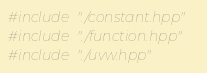<code> <loc_0><loc_0><loc_500><loc_500><_C++_>#include "./constant.hpp"
#include "./function.hpp"
#include "./uvw.hpp"</code> 